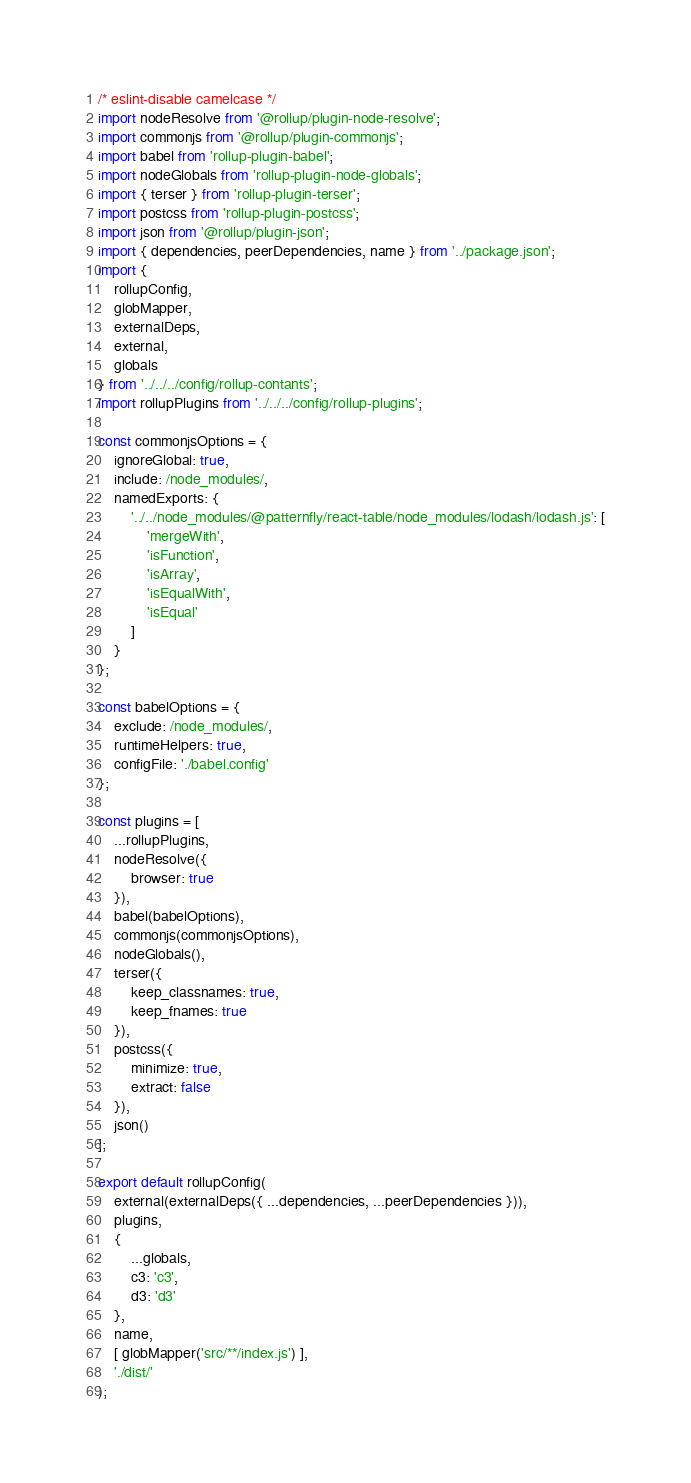<code> <loc_0><loc_0><loc_500><loc_500><_JavaScript_>/* eslint-disable camelcase */
import nodeResolve from '@rollup/plugin-node-resolve';
import commonjs from '@rollup/plugin-commonjs';
import babel from 'rollup-plugin-babel';
import nodeGlobals from 'rollup-plugin-node-globals';
import { terser } from 'rollup-plugin-terser';
import postcss from 'rollup-plugin-postcss';
import json from '@rollup/plugin-json';
import { dependencies, peerDependencies, name } from '../package.json';
import {
    rollupConfig,
    globMapper,
    externalDeps,
    external,
    globals
} from '../../../config/rollup-contants';
import rollupPlugins from '../../../config/rollup-plugins';

const commonjsOptions = {
    ignoreGlobal: true,
    include: /node_modules/,
    namedExports: {
        '../../node_modules/@patternfly/react-table/node_modules/lodash/lodash.js': [
            'mergeWith',
            'isFunction',
            'isArray',
            'isEqualWith',
            'isEqual'
        ]
    }
};

const babelOptions = {
    exclude: /node_modules/,
    runtimeHelpers: true,
    configFile: './babel.config'
};

const plugins = [
    ...rollupPlugins,
    nodeResolve({
        browser: true
    }),
    babel(babelOptions),
    commonjs(commonjsOptions),
    nodeGlobals(),
    terser({
        keep_classnames: true,
        keep_fnames: true
    }),
    postcss({
        minimize: true,
        extract: false
    }),
    json()
];

export default rollupConfig(
    external(externalDeps({ ...dependencies, ...peerDependencies })),
    plugins,
    {
        ...globals,
        c3: 'c3',
        d3: 'd3'
    },
    name,
    [ globMapper('src/**/index.js') ],
    './dist/'
);
</code> 